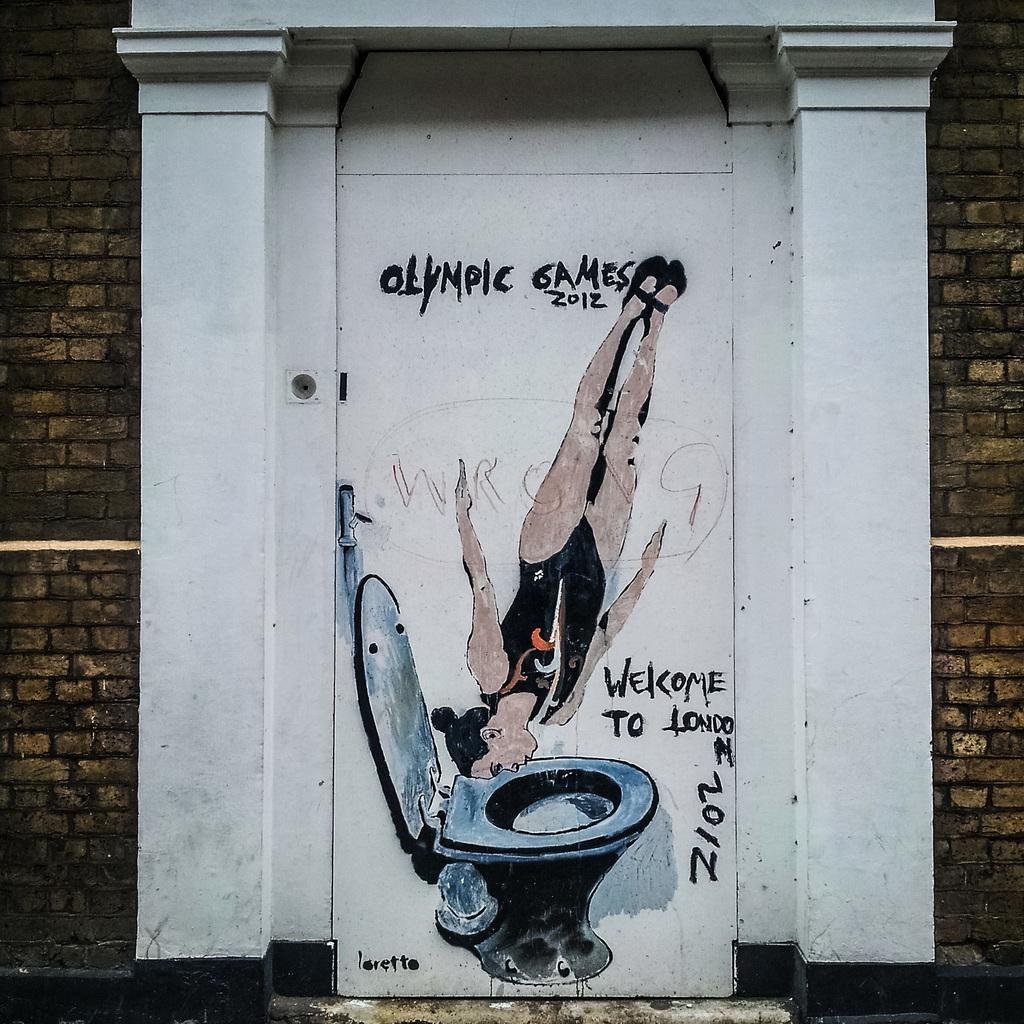<image>
Render a clear and concise summary of the photo. A woman diving into a toilet along with Olympic Games 2012 are painted on an outside door. 